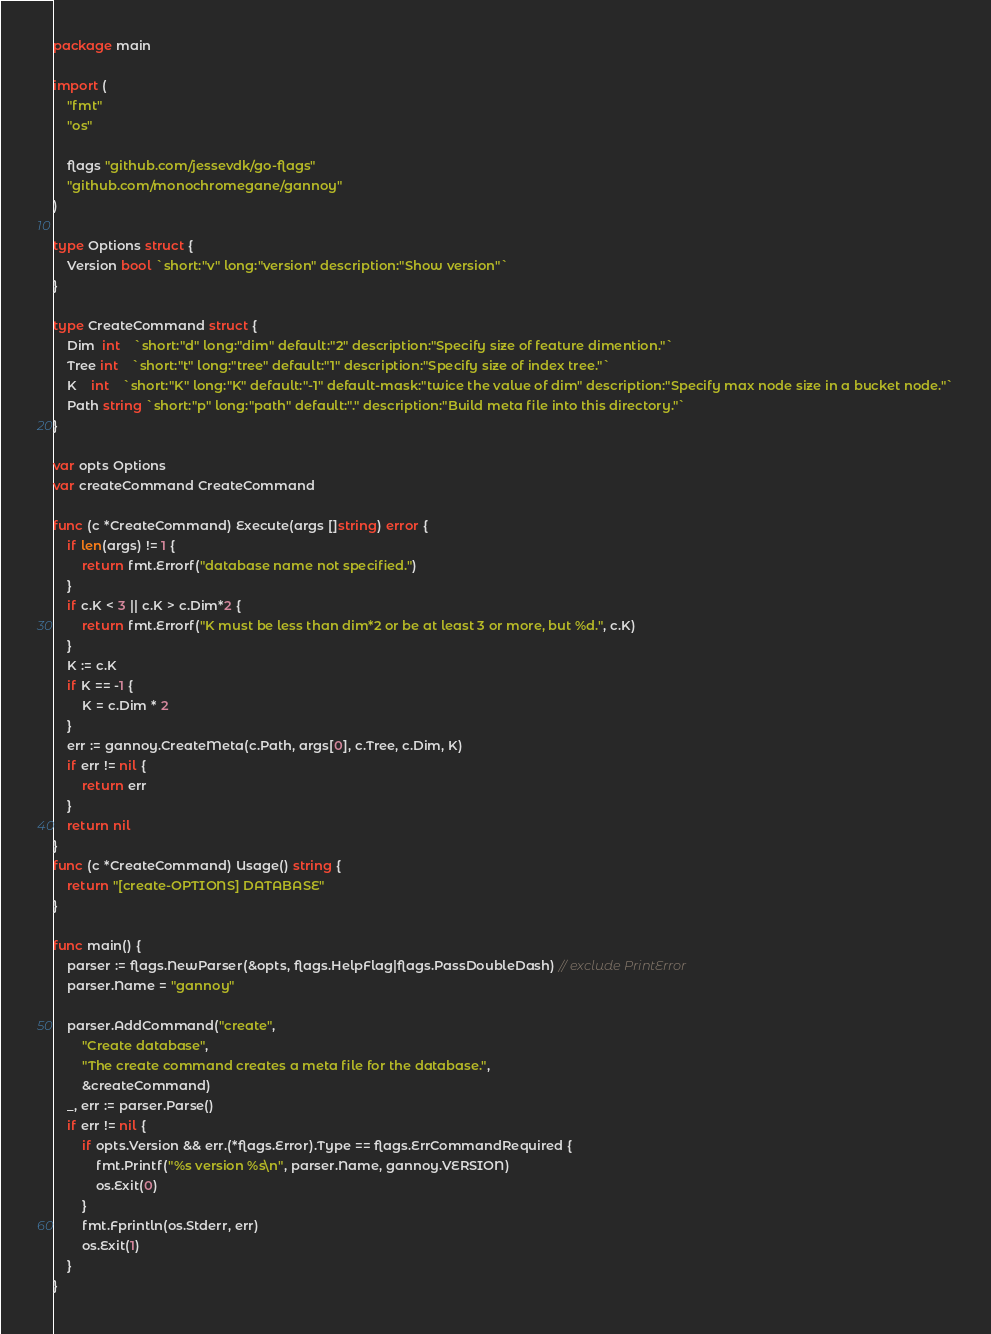<code> <loc_0><loc_0><loc_500><loc_500><_Go_>package main

import (
	"fmt"
	"os"

	flags "github.com/jessevdk/go-flags"
	"github.com/monochromegane/gannoy"
)

type Options struct {
	Version bool `short:"v" long:"version" description:"Show version"`
}

type CreateCommand struct {
	Dim  int    `short:"d" long:"dim" default:"2" description:"Specify size of feature dimention."`
	Tree int    `short:"t" long:"tree" default:"1" description:"Specify size of index tree."`
	K    int    `short:"K" long:"K" default:"-1" default-mask:"twice the value of dim" description:"Specify max node size in a bucket node."`
	Path string `short:"p" long:"path" default:"." description:"Build meta file into this directory."`
}

var opts Options
var createCommand CreateCommand

func (c *CreateCommand) Execute(args []string) error {
	if len(args) != 1 {
		return fmt.Errorf("database name not specified.")
	}
	if c.K < 3 || c.K > c.Dim*2 {
		return fmt.Errorf("K must be less than dim*2 or be at least 3 or more, but %d.", c.K)
	}
	K := c.K
	if K == -1 {
		K = c.Dim * 2
	}
	err := gannoy.CreateMeta(c.Path, args[0], c.Tree, c.Dim, K)
	if err != nil {
		return err
	}
	return nil
}
func (c *CreateCommand) Usage() string {
	return "[create-OPTIONS] DATABASE"
}

func main() {
	parser := flags.NewParser(&opts, flags.HelpFlag|flags.PassDoubleDash) // exclude PrintError
	parser.Name = "gannoy"

	parser.AddCommand("create",
		"Create database",
		"The create command creates a meta file for the database.",
		&createCommand)
	_, err := parser.Parse()
	if err != nil {
		if opts.Version && err.(*flags.Error).Type == flags.ErrCommandRequired {
			fmt.Printf("%s version %s\n", parser.Name, gannoy.VERSION)
			os.Exit(0)
		}
		fmt.Fprintln(os.Stderr, err)
		os.Exit(1)
	}
}
</code> 